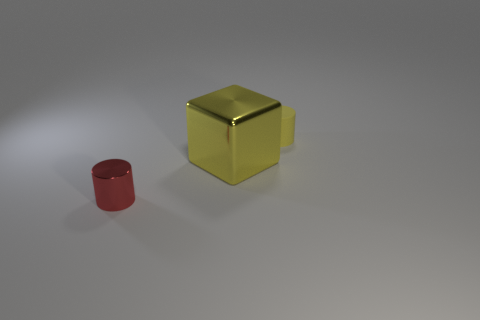Add 1 matte things. How many objects exist? 4 Subtract all red cylinders. How many cylinders are left? 1 Subtract 1 blocks. How many blocks are left? 0 Subtract all cylinders. How many objects are left? 1 Subtract 0 gray cylinders. How many objects are left? 3 Subtract all brown cubes. Subtract all cyan balls. How many cubes are left? 1 Subtract all gray cubes. How many red cylinders are left? 1 Subtract all cyan rubber blocks. Subtract all big yellow metal things. How many objects are left? 2 Add 1 big metallic things. How many big metallic things are left? 2 Add 2 cylinders. How many cylinders exist? 4 